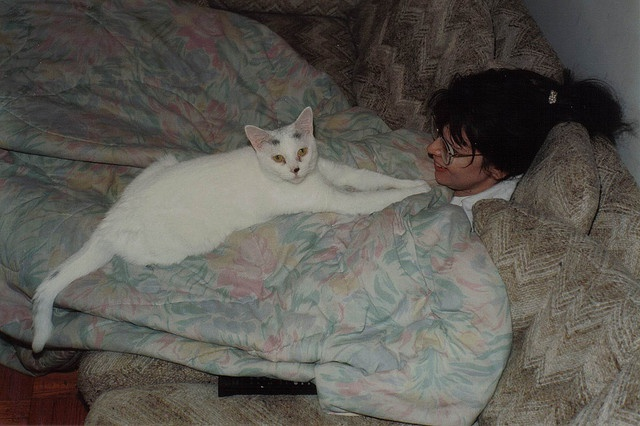Describe the objects in this image and their specific colors. I can see bed in gray, black, and darkgray tones, couch in gray and black tones, cat in black, darkgray, and gray tones, people in black, gray, and maroon tones, and remote in black and gray tones in this image. 